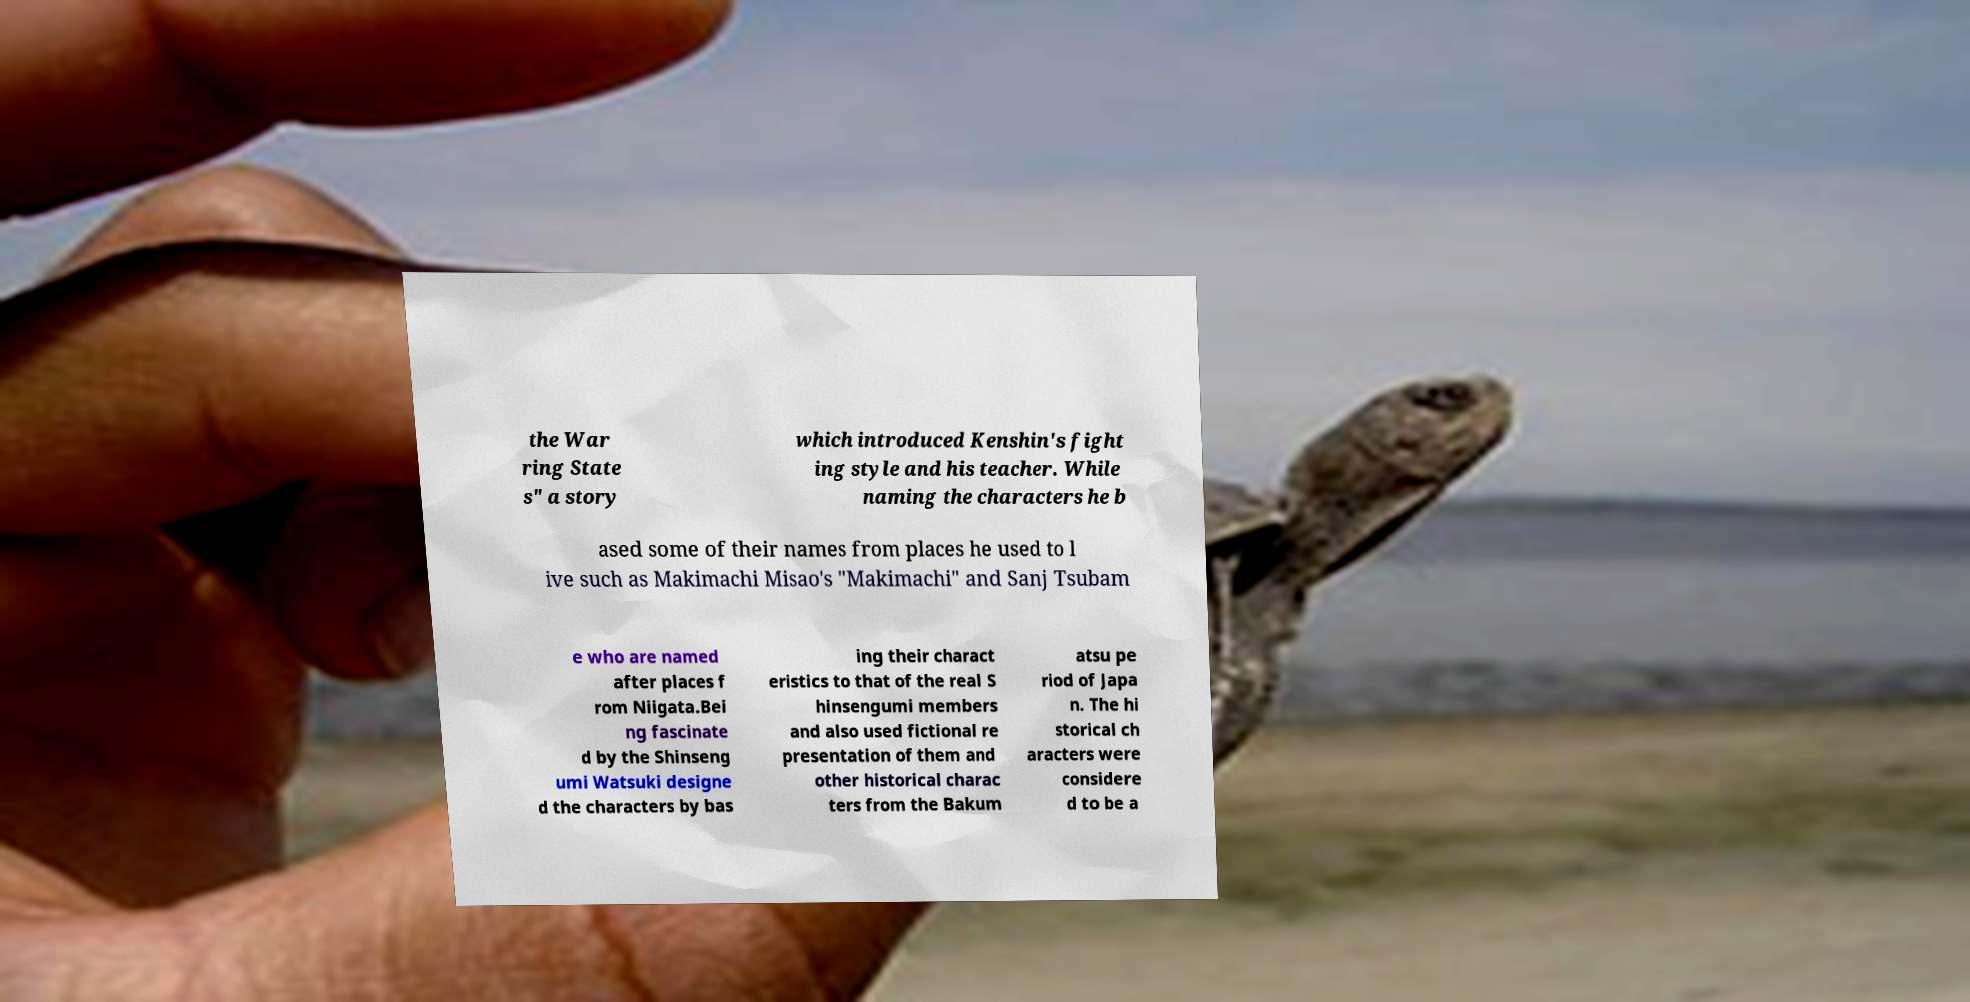There's text embedded in this image that I need extracted. Can you transcribe it verbatim? the War ring State s" a story which introduced Kenshin's fight ing style and his teacher. While naming the characters he b ased some of their names from places he used to l ive such as Makimachi Misao's "Makimachi" and Sanj Tsubam e who are named after places f rom Niigata.Bei ng fascinate d by the Shinseng umi Watsuki designe d the characters by bas ing their charact eristics to that of the real S hinsengumi members and also used fictional re presentation of them and other historical charac ters from the Bakum atsu pe riod of Japa n. The hi storical ch aracters were considere d to be a 